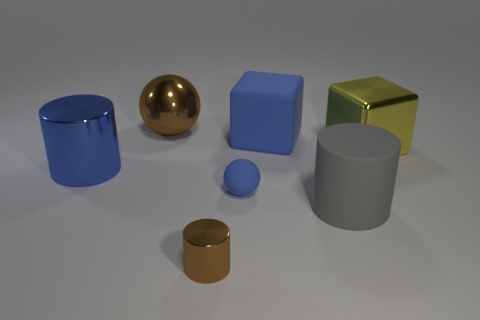Add 1 tiny cyan rubber cubes. How many objects exist? 8 Subtract all cubes. How many objects are left? 5 Add 7 metallic blocks. How many metallic blocks exist? 8 Subtract 0 green cylinders. How many objects are left? 7 Subtract all large red spheres. Subtract all blue cylinders. How many objects are left? 6 Add 1 matte spheres. How many matte spheres are left? 2 